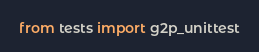Convert code to text. <code><loc_0><loc_0><loc_500><loc_500><_Python_>from tests import g2p_unittest
</code> 